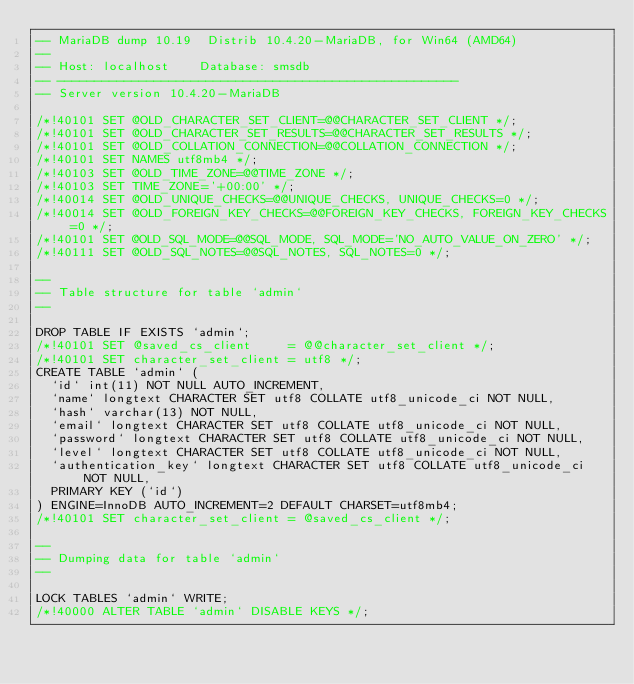Convert code to text. <code><loc_0><loc_0><loc_500><loc_500><_SQL_>-- MariaDB dump 10.19  Distrib 10.4.20-MariaDB, for Win64 (AMD64)
--
-- Host: localhost    Database: smsdb
-- ------------------------------------------------------
-- Server version	10.4.20-MariaDB

/*!40101 SET @OLD_CHARACTER_SET_CLIENT=@@CHARACTER_SET_CLIENT */;
/*!40101 SET @OLD_CHARACTER_SET_RESULTS=@@CHARACTER_SET_RESULTS */;
/*!40101 SET @OLD_COLLATION_CONNECTION=@@COLLATION_CONNECTION */;
/*!40101 SET NAMES utf8mb4 */;
/*!40103 SET @OLD_TIME_ZONE=@@TIME_ZONE */;
/*!40103 SET TIME_ZONE='+00:00' */;
/*!40014 SET @OLD_UNIQUE_CHECKS=@@UNIQUE_CHECKS, UNIQUE_CHECKS=0 */;
/*!40014 SET @OLD_FOREIGN_KEY_CHECKS=@@FOREIGN_KEY_CHECKS, FOREIGN_KEY_CHECKS=0 */;
/*!40101 SET @OLD_SQL_MODE=@@SQL_MODE, SQL_MODE='NO_AUTO_VALUE_ON_ZERO' */;
/*!40111 SET @OLD_SQL_NOTES=@@SQL_NOTES, SQL_NOTES=0 */;

--
-- Table structure for table `admin`
--

DROP TABLE IF EXISTS `admin`;
/*!40101 SET @saved_cs_client     = @@character_set_client */;
/*!40101 SET character_set_client = utf8 */;
CREATE TABLE `admin` (
  `id` int(11) NOT NULL AUTO_INCREMENT,
  `name` longtext CHARACTER SET utf8 COLLATE utf8_unicode_ci NOT NULL,
  `hash` varchar(13) NOT NULL,
  `email` longtext CHARACTER SET utf8 COLLATE utf8_unicode_ci NOT NULL,
  `password` longtext CHARACTER SET utf8 COLLATE utf8_unicode_ci NOT NULL,
  `level` longtext CHARACTER SET utf8 COLLATE utf8_unicode_ci NOT NULL,
  `authentication_key` longtext CHARACTER SET utf8 COLLATE utf8_unicode_ci NOT NULL,
  PRIMARY KEY (`id`)
) ENGINE=InnoDB AUTO_INCREMENT=2 DEFAULT CHARSET=utf8mb4;
/*!40101 SET character_set_client = @saved_cs_client */;

--
-- Dumping data for table `admin`
--

LOCK TABLES `admin` WRITE;
/*!40000 ALTER TABLE `admin` DISABLE KEYS */;</code> 